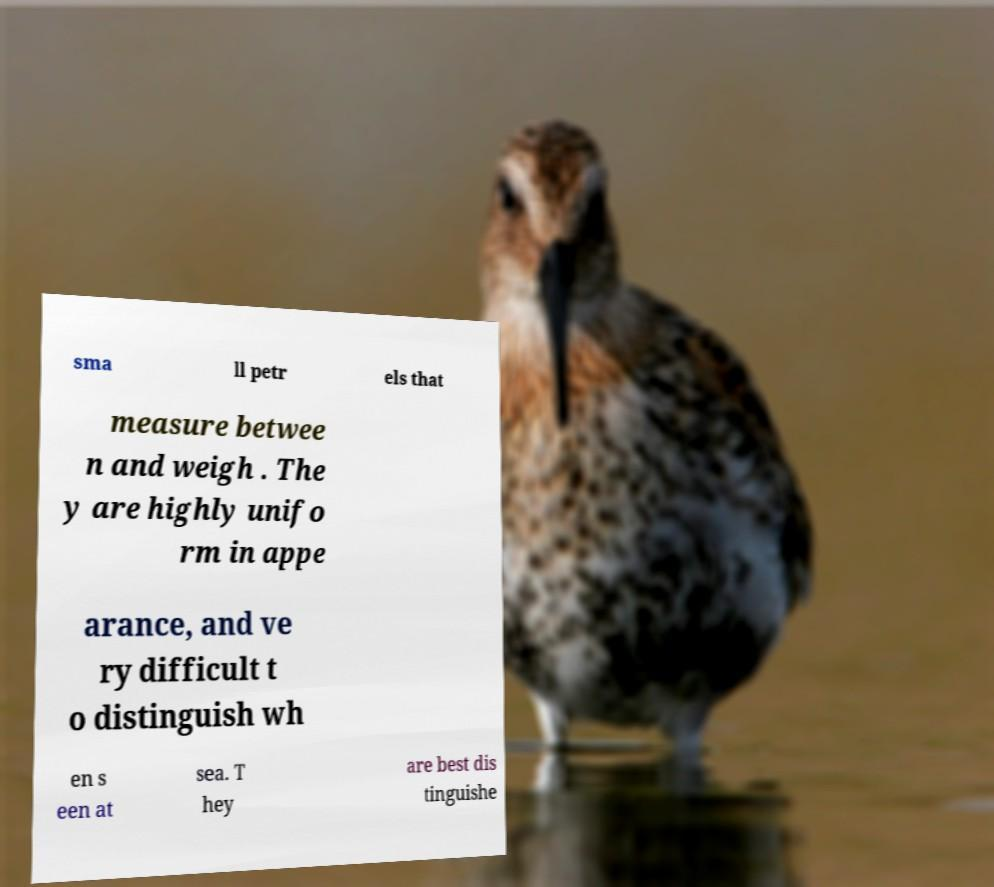Please identify and transcribe the text found in this image. sma ll petr els that measure betwee n and weigh . The y are highly unifo rm in appe arance, and ve ry difficult t o distinguish wh en s een at sea. T hey are best dis tinguishe 